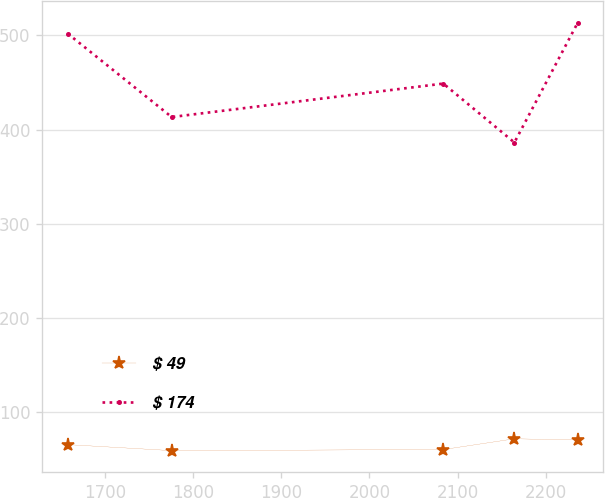<chart> <loc_0><loc_0><loc_500><loc_500><line_chart><ecel><fcel>$ 49<fcel>$ 174<nl><fcel>1657.92<fcel>65.19<fcel>502.02<nl><fcel>1775.84<fcel>58.8<fcel>413.32<nl><fcel>2083.87<fcel>59.95<fcel>448.89<nl><fcel>2164.45<fcel>71.36<fcel>386.27<nl><fcel>2236.37<fcel>70.21<fcel>513.76<nl></chart> 